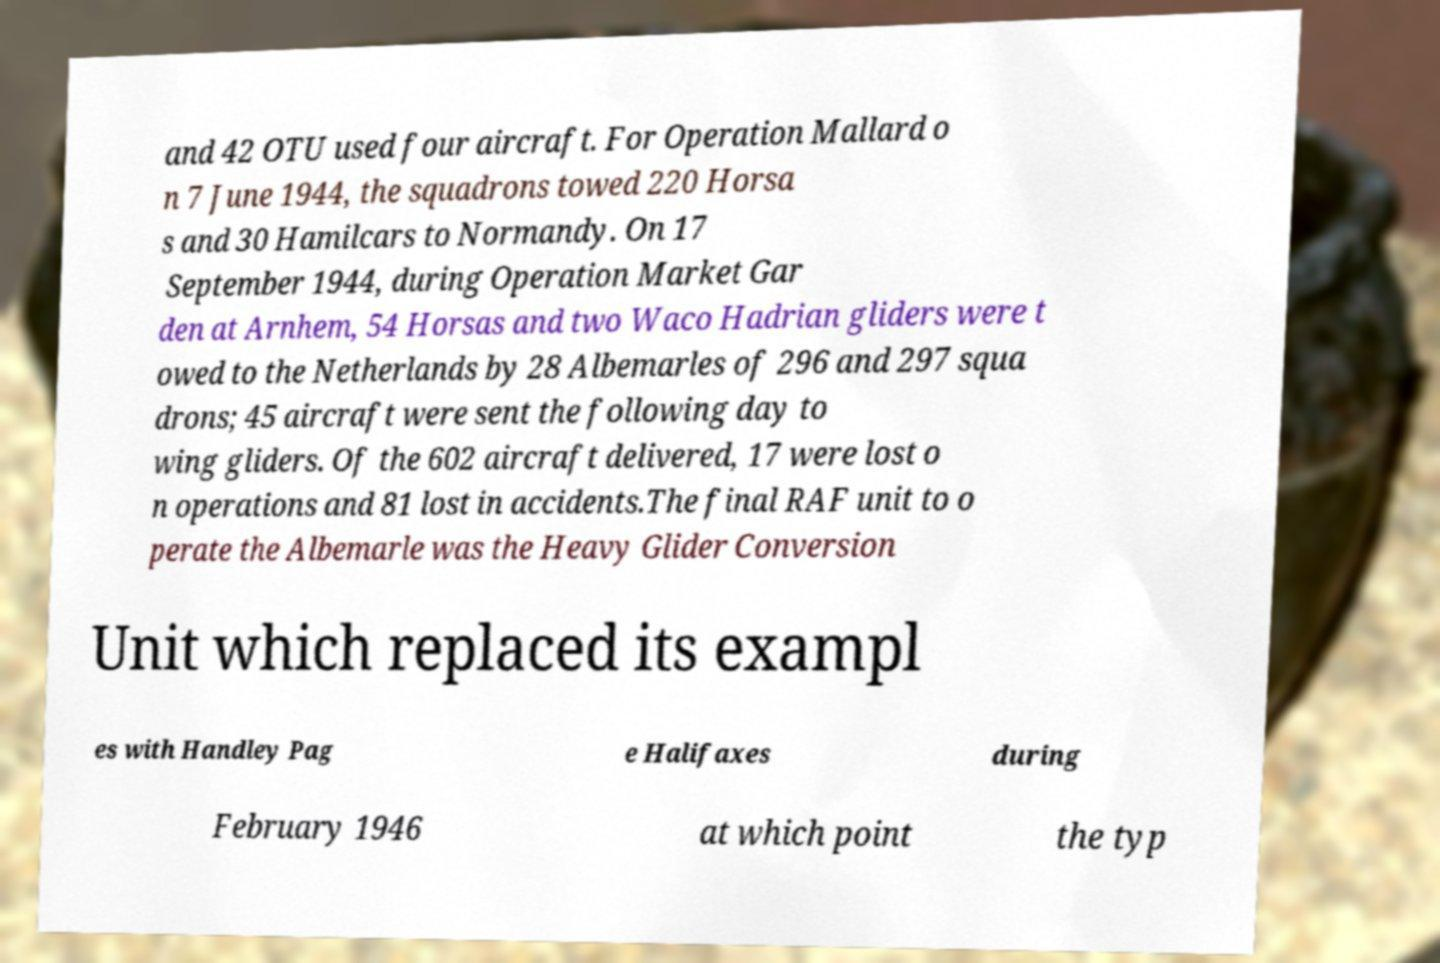Please read and relay the text visible in this image. What does it say? and 42 OTU used four aircraft. For Operation Mallard o n 7 June 1944, the squadrons towed 220 Horsa s and 30 Hamilcars to Normandy. On 17 September 1944, during Operation Market Gar den at Arnhem, 54 Horsas and two Waco Hadrian gliders were t owed to the Netherlands by 28 Albemarles of 296 and 297 squa drons; 45 aircraft were sent the following day to wing gliders. Of the 602 aircraft delivered, 17 were lost o n operations and 81 lost in accidents.The final RAF unit to o perate the Albemarle was the Heavy Glider Conversion Unit which replaced its exampl es with Handley Pag e Halifaxes during February 1946 at which point the typ 